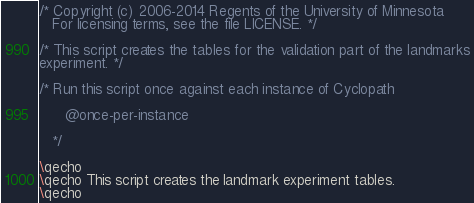Convert code to text. <code><loc_0><loc_0><loc_500><loc_500><_SQL_>/* Copyright (c) 2006-2014 Regents of the University of Minnesota
   For licensing terms, see the file LICENSE. */

/* This script creates the tables for the validation part of the landmarks
experiment. */

/* Run this script once against each instance of Cyclopath

      @once-per-instance

   */

\qecho
\qecho This script creates the landmark experiment tables.
\qecho
</code> 